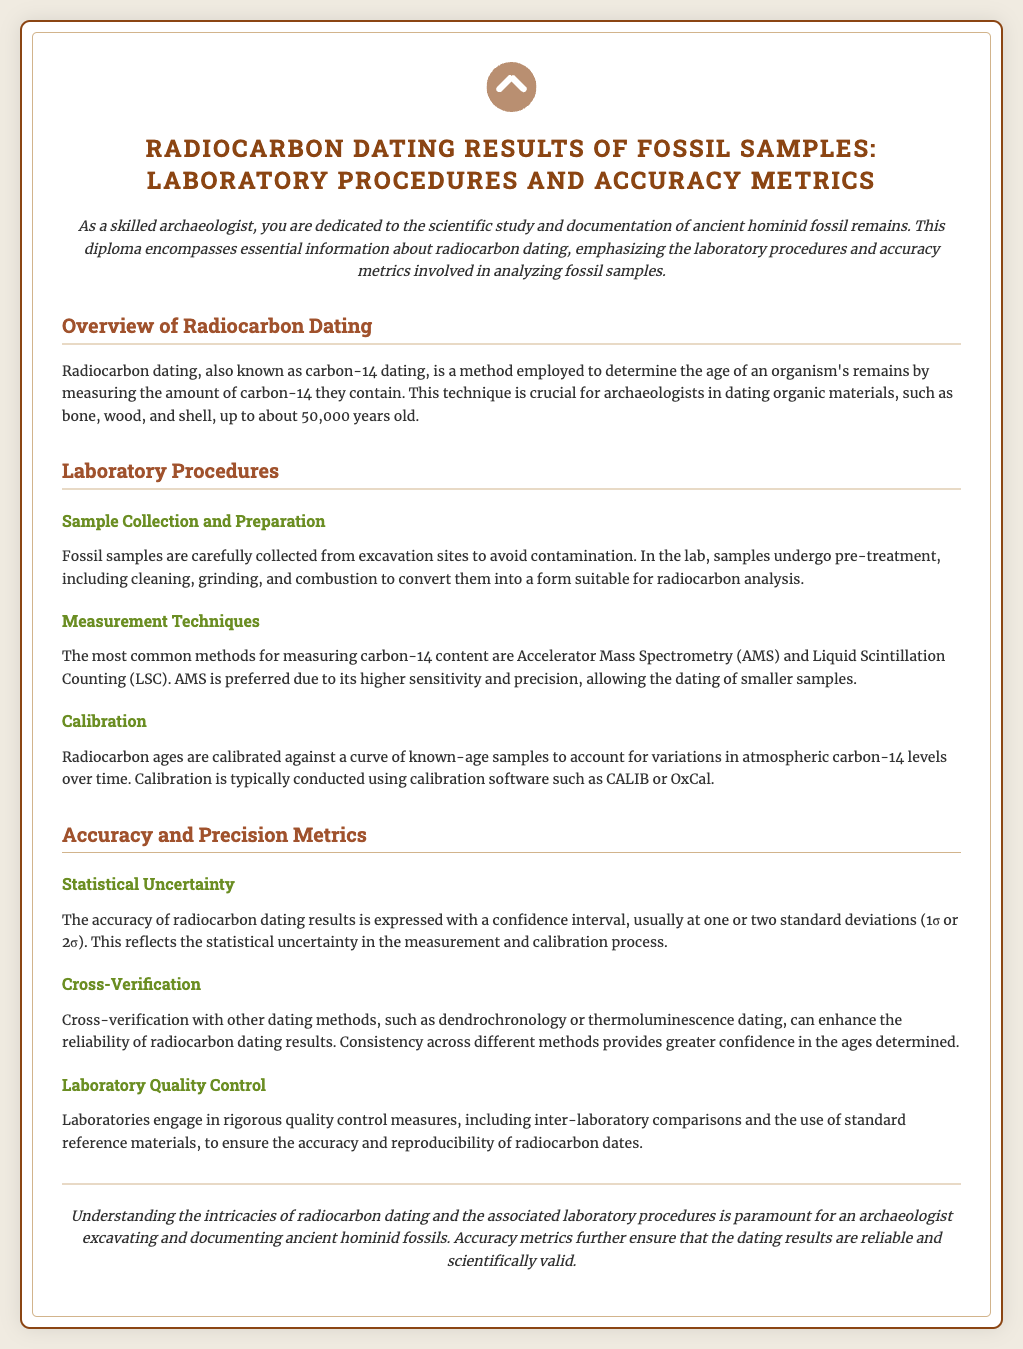what is radiocarbon dating also known as? Radiocarbon dating is also referred to as carbon-14 dating in the document.
Answer: carbon-14 dating what is the maximum age for dating organic materials using radiocarbon dating? The document states that radiocarbon dating can be used to date organic materials up to about 50,000 years old.
Answer: 50,000 years what is the preferred measurement technique for radiocarbon dating? The document mentions that Accelerator Mass Spectrometry (AMS) is the preferred method due to its higher sensitivity and precision.
Answer: Accelerator Mass Spectrometry what software is commonly used for calibration in radiocarbon dating? The document lists CALIB or OxCal as calibration software commonly used for radiocarbon dating.
Answer: CALIB or OxCal what does the statistical uncertainty in radiocarbon dating results reflect? The document explains that statistical uncertainty reflects the confidence interval at one or two standard deviations in the measurement and calibration process.
Answer: confidence interval what enhances the reliability of radiocarbon dating results? The document states that cross-verification with other dating methods can enhance reliability.
Answer: cross-verification how do laboratories ensure the accuracy of radiocarbon dates? The document states laboratories engage in rigorous quality control measures, including inter-laboratory comparisons.
Answer: quality control measures what must be avoided when collecting fossil samples? The document emphasizes that contamination must be avoided when collecting fossil samples.
Answer: contamination what is the primary focus of the diploma document? The document focuses on the radiocarbon dating results of fossil samples, including laboratory procedures and accuracy metrics.
Answer: radiocarbon dating results 